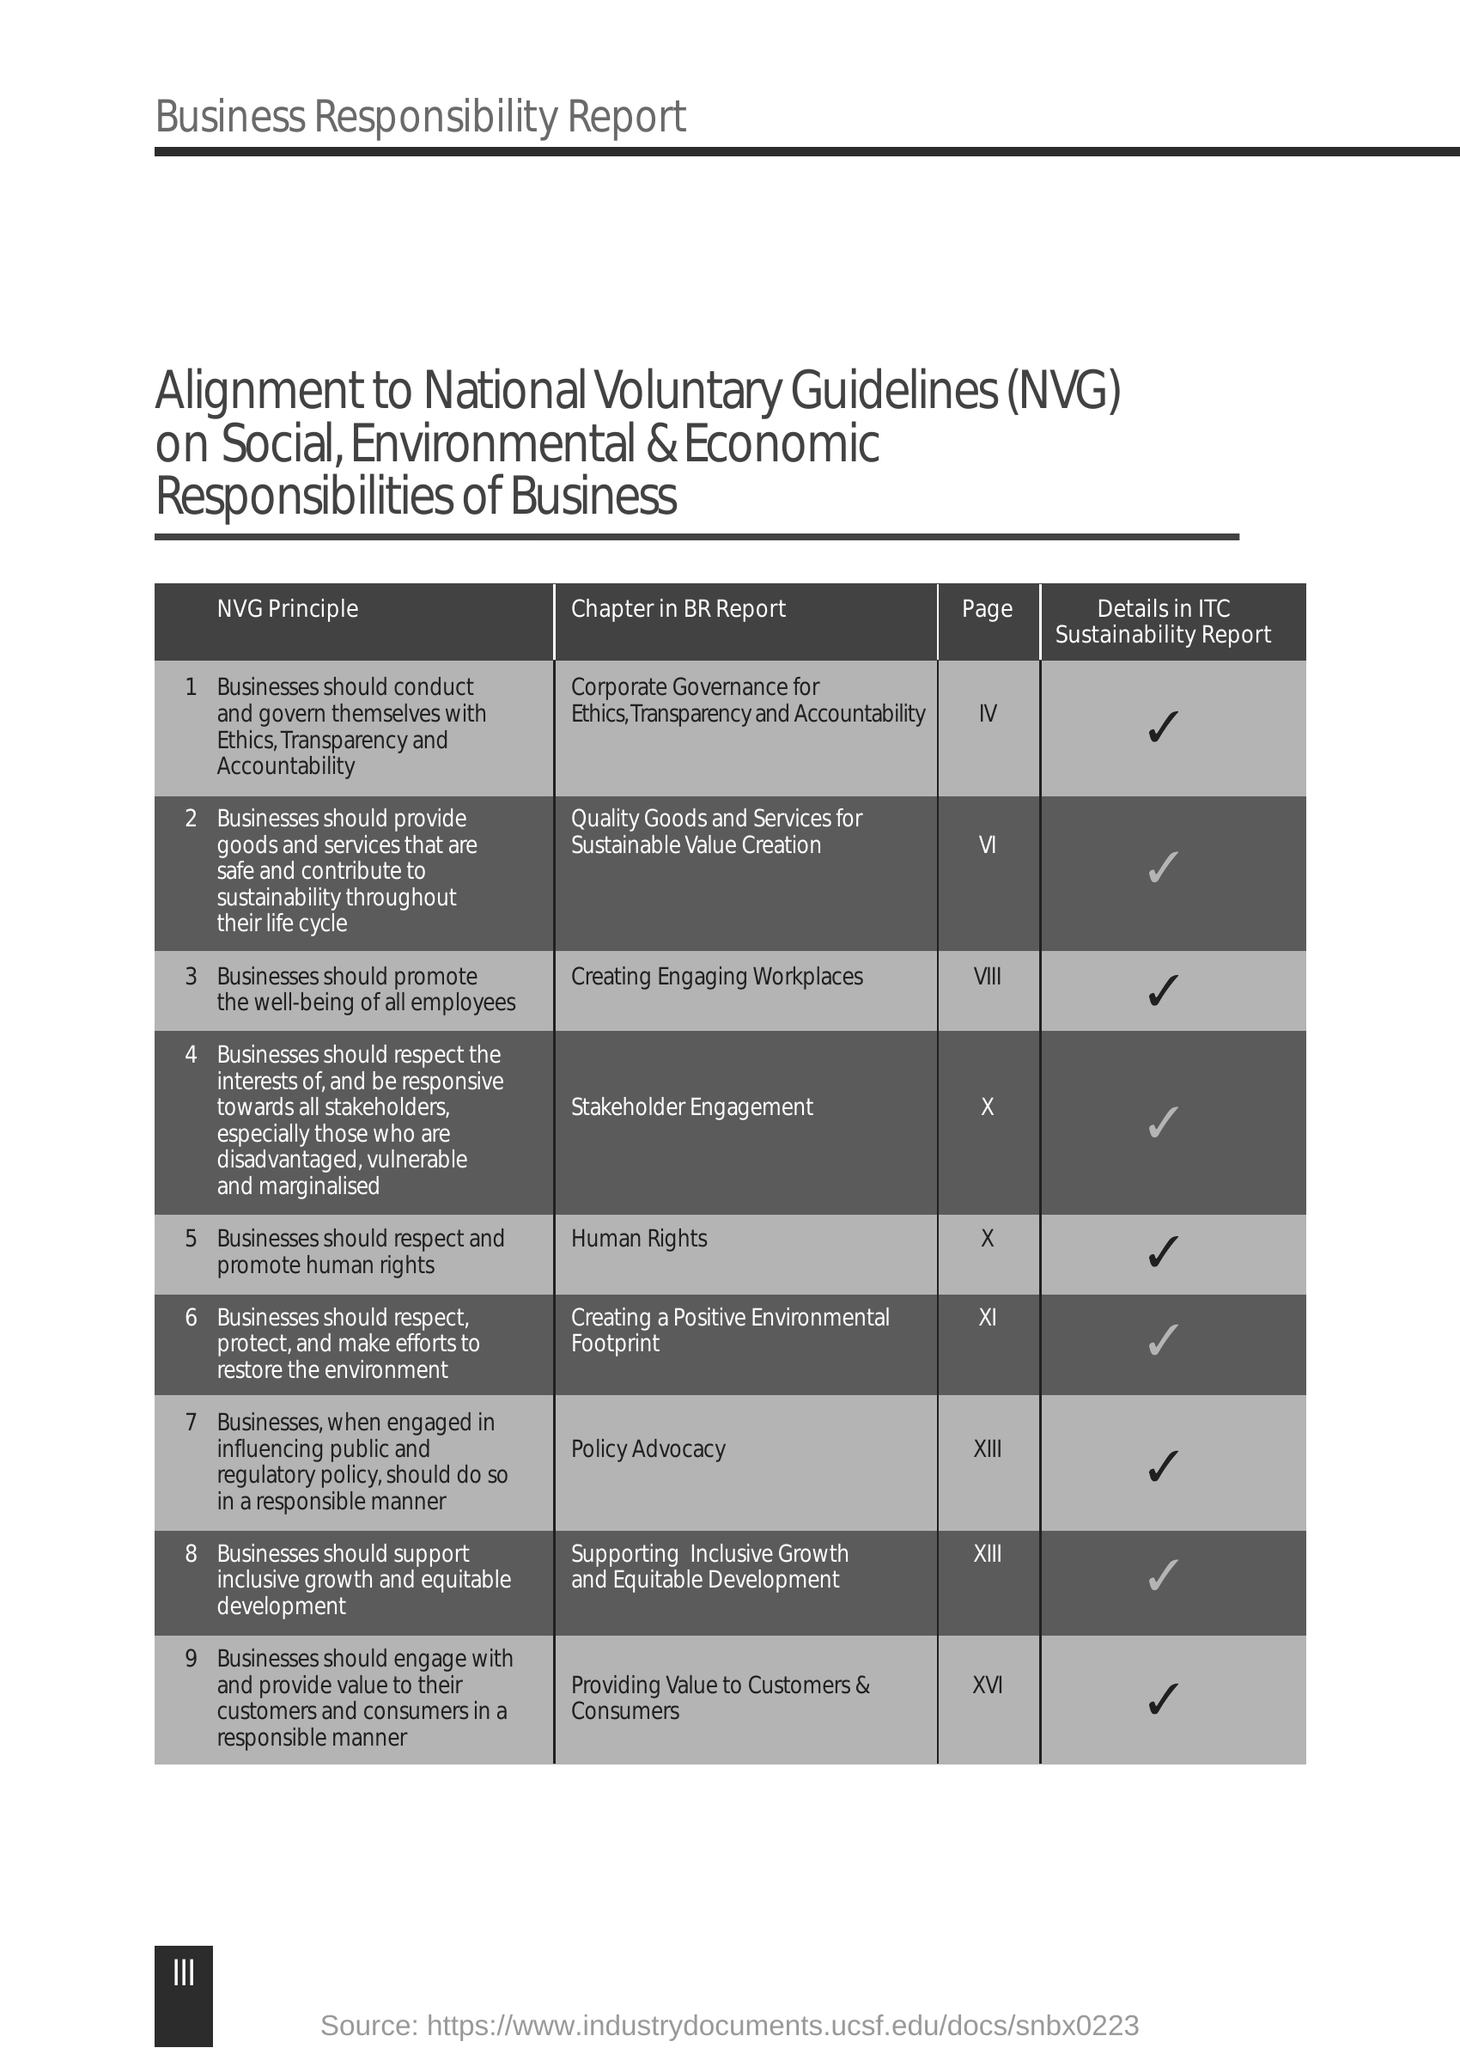Indicate a few pertinent items in this graphic. The full form of NVG is "National Voluntary Guidelines." These guidelines are a set of principles and best practices for voluntary organizations in India. 